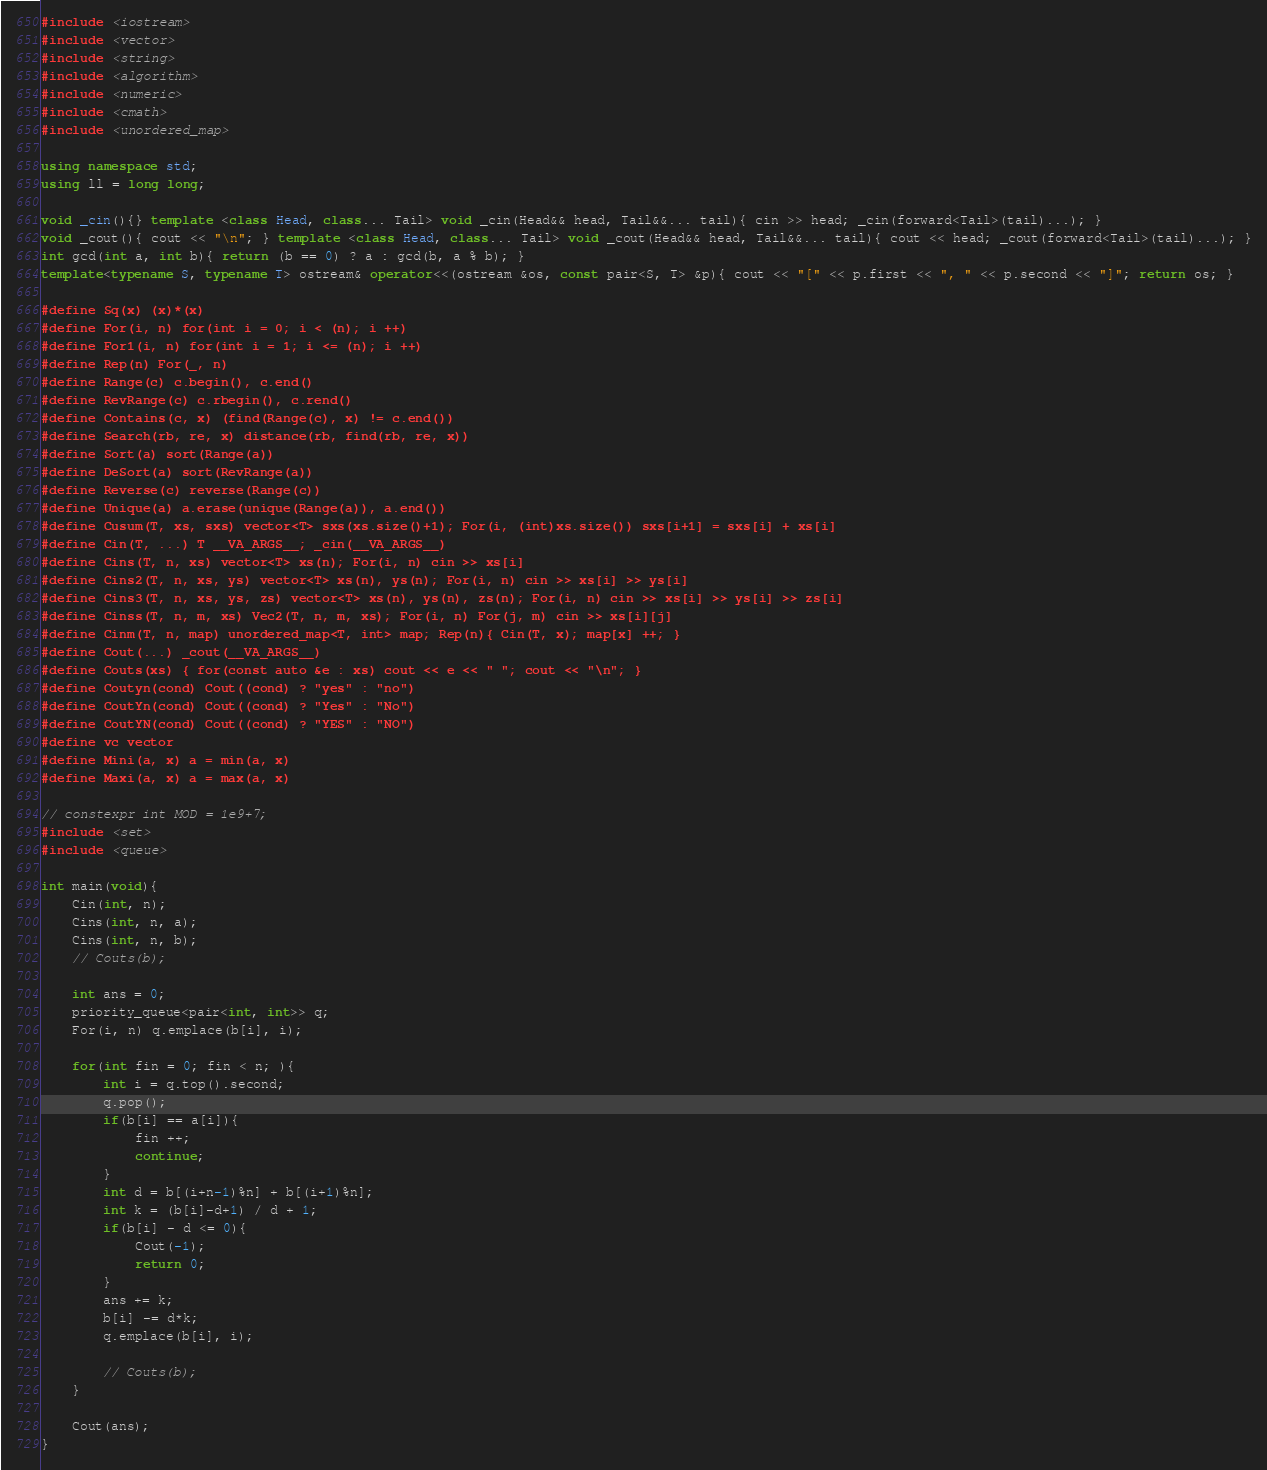<code> <loc_0><loc_0><loc_500><loc_500><_C++_>#include <iostream>
#include <vector>
#include <string>
#include <algorithm>
#include <numeric>
#include <cmath>
#include <unordered_map>

using namespace std;
using ll = long long;

void _cin(){} template <class Head, class... Tail> void _cin(Head&& head, Tail&&... tail){ cin >> head; _cin(forward<Tail>(tail)...); }
void _cout(){ cout << "\n"; } template <class Head, class... Tail> void _cout(Head&& head, Tail&&... tail){ cout << head; _cout(forward<Tail>(tail)...); }
int gcd(int a, int b){ return (b == 0) ? a : gcd(b, a % b); }
template<typename S, typename T> ostream& operator<<(ostream &os, const pair<S, T> &p){ cout << "[" << p.first << ", " << p.second << "]"; return os; }

#define Sq(x) (x)*(x)
#define For(i, n) for(int i = 0; i < (n); i ++)
#define For1(i, n) for(int i = 1; i <= (n); i ++)
#define Rep(n) For(_, n)
#define Range(c) c.begin(), c.end()
#define RevRange(c) c.rbegin(), c.rend()
#define Contains(c, x) (find(Range(c), x) != c.end())
#define Search(rb, re, x) distance(rb, find(rb, re, x))
#define Sort(a) sort(Range(a))
#define DeSort(a) sort(RevRange(a))
#define Reverse(c) reverse(Range(c))
#define Unique(a) a.erase(unique(Range(a)), a.end())
#define Cusum(T, xs, sxs) vector<T> sxs(xs.size()+1); For(i, (int)xs.size()) sxs[i+1] = sxs[i] + xs[i]
#define Cin(T, ...) T __VA_ARGS__; _cin(__VA_ARGS__)
#define Cins(T, n, xs) vector<T> xs(n); For(i, n) cin >> xs[i]
#define Cins2(T, n, xs, ys) vector<T> xs(n), ys(n); For(i, n) cin >> xs[i] >> ys[i]
#define Cins3(T, n, xs, ys, zs) vector<T> xs(n), ys(n), zs(n); For(i, n) cin >> xs[i] >> ys[i] >> zs[i]
#define Cinss(T, n, m, xs) Vec2(T, n, m, xs); For(i, n) For(j, m) cin >> xs[i][j]
#define Cinm(T, n, map) unordered_map<T, int> map; Rep(n){ Cin(T, x); map[x] ++; }
#define Cout(...) _cout(__VA_ARGS__)
#define Couts(xs) { for(const auto &e : xs) cout << e << " "; cout << "\n"; }
#define Coutyn(cond) Cout((cond) ? "yes" : "no")
#define CoutYn(cond) Cout((cond) ? "Yes" : "No")
#define CoutYN(cond) Cout((cond) ? "YES" : "NO")
#define vc vector
#define Mini(a, x) a = min(a, x)
#define Maxi(a, x) a = max(a, x)

// constexpr int MOD = 1e9+7;
#include <set>
#include <queue>

int main(void){
    Cin(int, n);
    Cins(int, n, a);
    Cins(int, n, b);
    // Couts(b);
    
    int ans = 0;
    priority_queue<pair<int, int>> q;
    For(i, n) q.emplace(b[i], i);
    
    for(int fin = 0; fin < n; ){
        int i = q.top().second;
        q.pop();
        if(b[i] == a[i]){
            fin ++;
            continue;
        }
        int d = b[(i+n-1)%n] + b[(i+1)%n];
        int k = (b[i]-d+1) / d + 1;
        if(b[i] - d <= 0){
            Cout(-1);
            return 0;
        }
        ans += k;
        b[i] -= d*k;
        q.emplace(b[i], i);
        
        // Couts(b);
    }

    Cout(ans);
}
</code> 